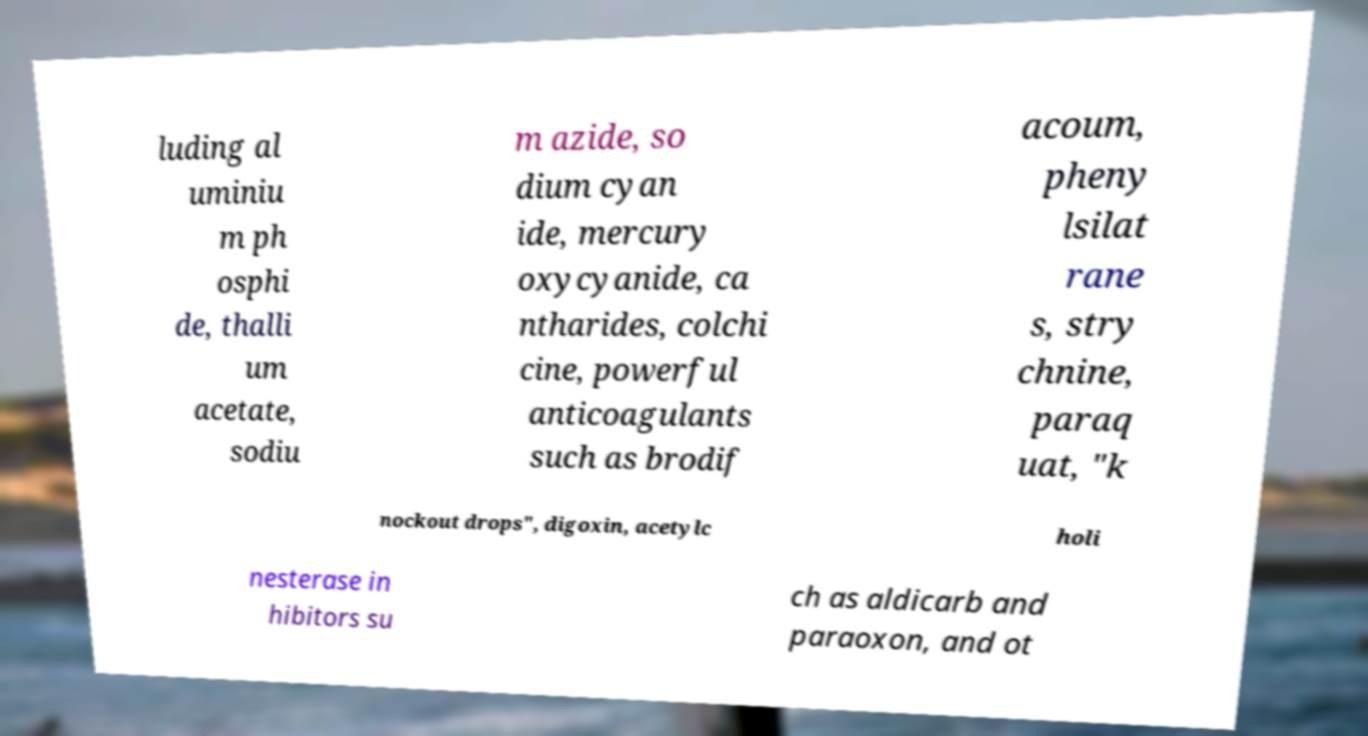Could you extract and type out the text from this image? luding al uminiu m ph osphi de, thalli um acetate, sodiu m azide, so dium cyan ide, mercury oxycyanide, ca ntharides, colchi cine, powerful anticoagulants such as brodif acoum, pheny lsilat rane s, stry chnine, paraq uat, "k nockout drops", digoxin, acetylc holi nesterase in hibitors su ch as aldicarb and paraoxon, and ot 